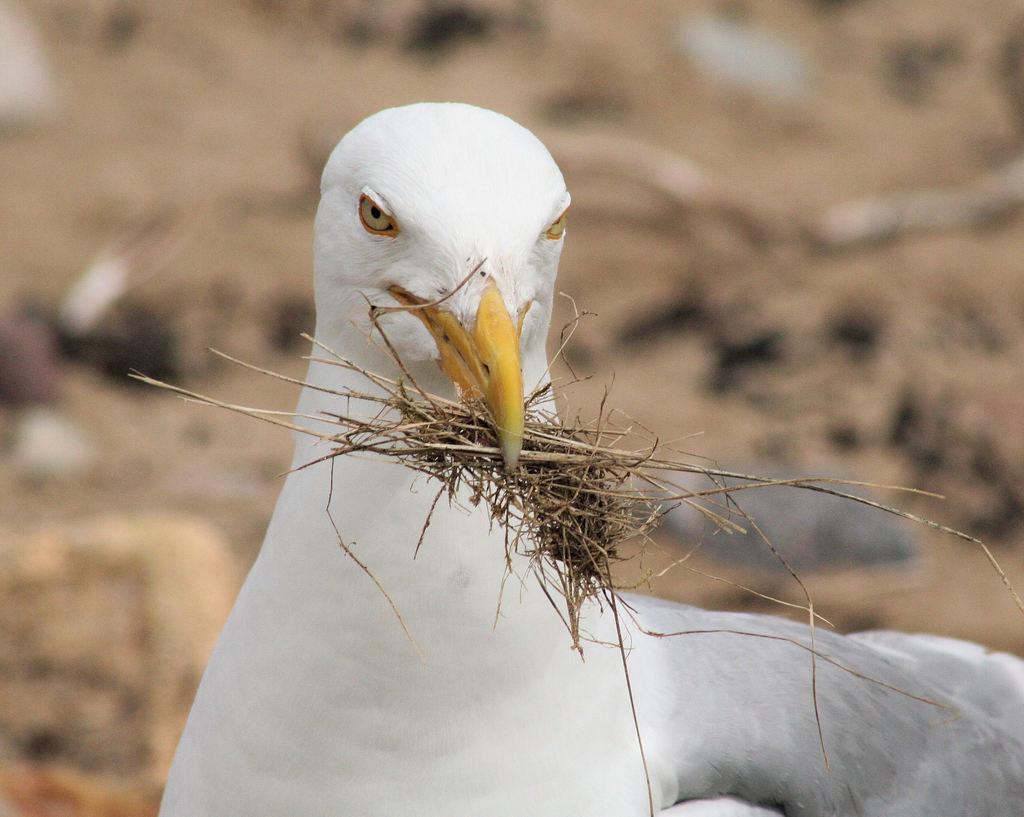Could you give a brief overview of what you see in this image? In the image there is a bird. And there is grass in the bird's beak. Behind the bird there is a blur background. 